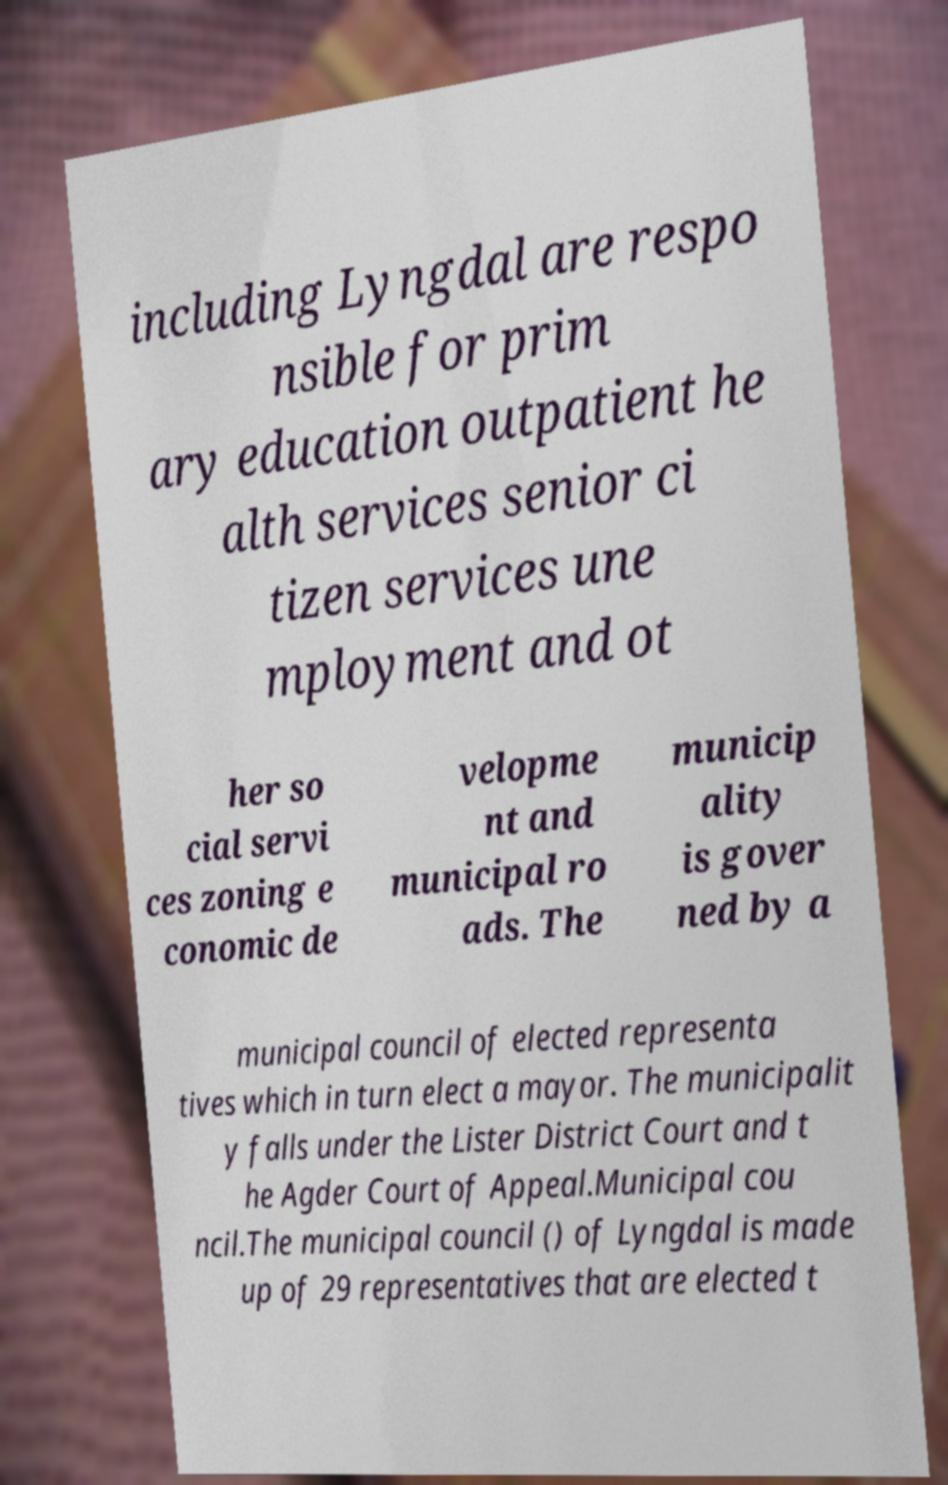Could you extract and type out the text from this image? including Lyngdal are respo nsible for prim ary education outpatient he alth services senior ci tizen services une mployment and ot her so cial servi ces zoning e conomic de velopme nt and municipal ro ads. The municip ality is gover ned by a municipal council of elected representa tives which in turn elect a mayor. The municipalit y falls under the Lister District Court and t he Agder Court of Appeal.Municipal cou ncil.The municipal council () of Lyngdal is made up of 29 representatives that are elected t 